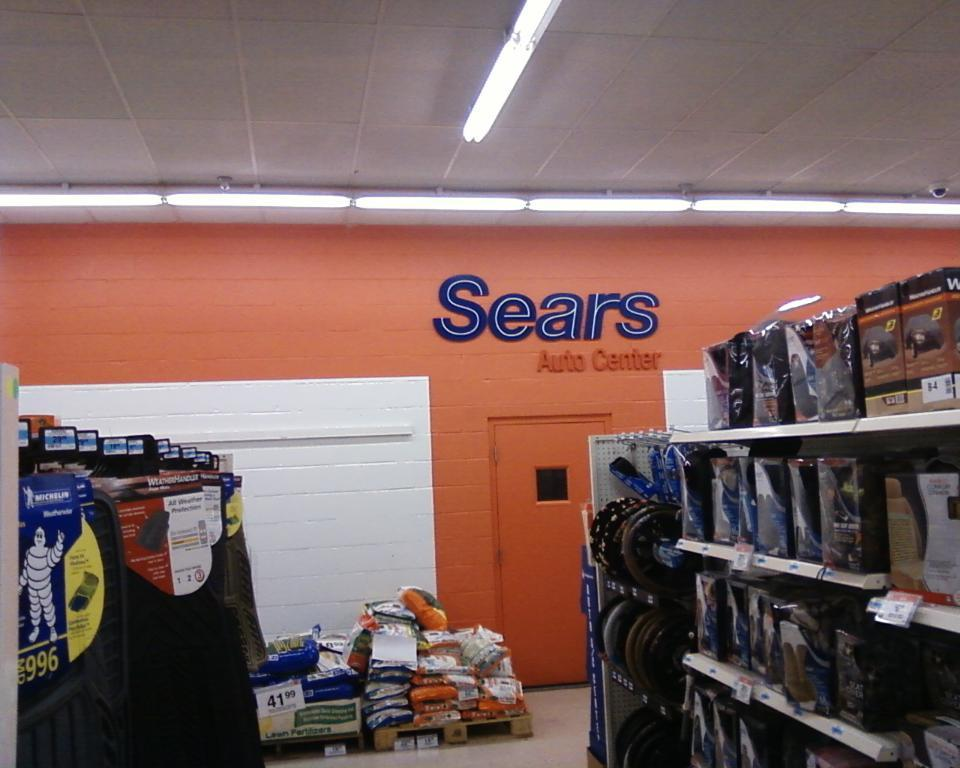<image>
Create a compact narrative representing the image presented. Automobile care and maintenance supplies are available at Sears. 